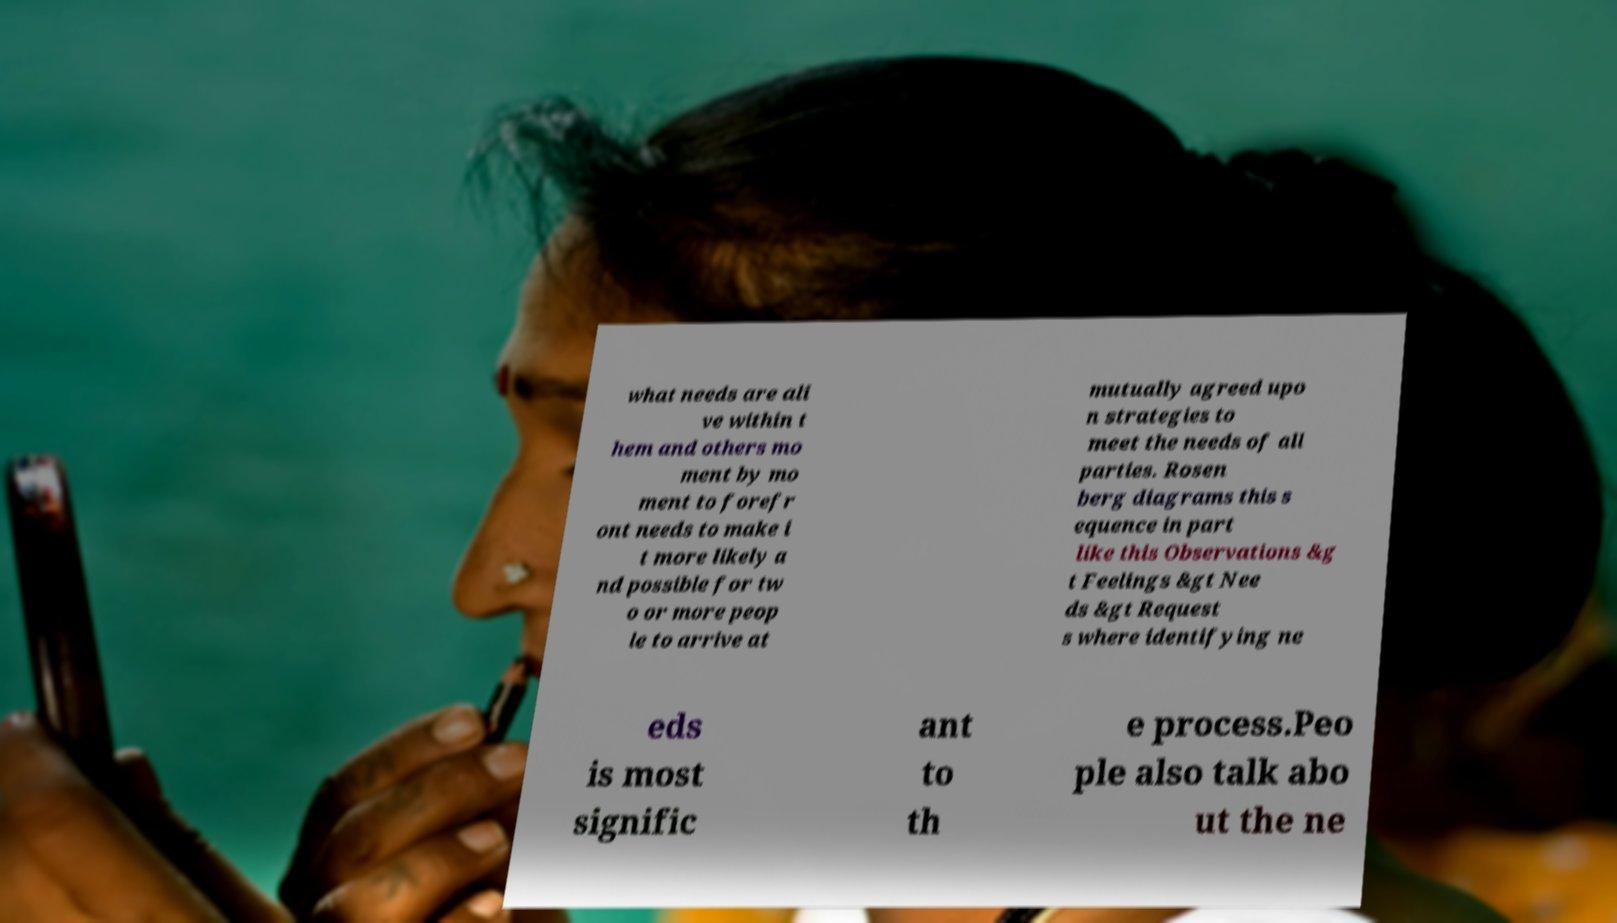Could you extract and type out the text from this image? what needs are ali ve within t hem and others mo ment by mo ment to forefr ont needs to make i t more likely a nd possible for tw o or more peop le to arrive at mutually agreed upo n strategies to meet the needs of all parties. Rosen berg diagrams this s equence in part like this Observations &g t Feelings &gt Nee ds &gt Request s where identifying ne eds is most signific ant to th e process.Peo ple also talk abo ut the ne 